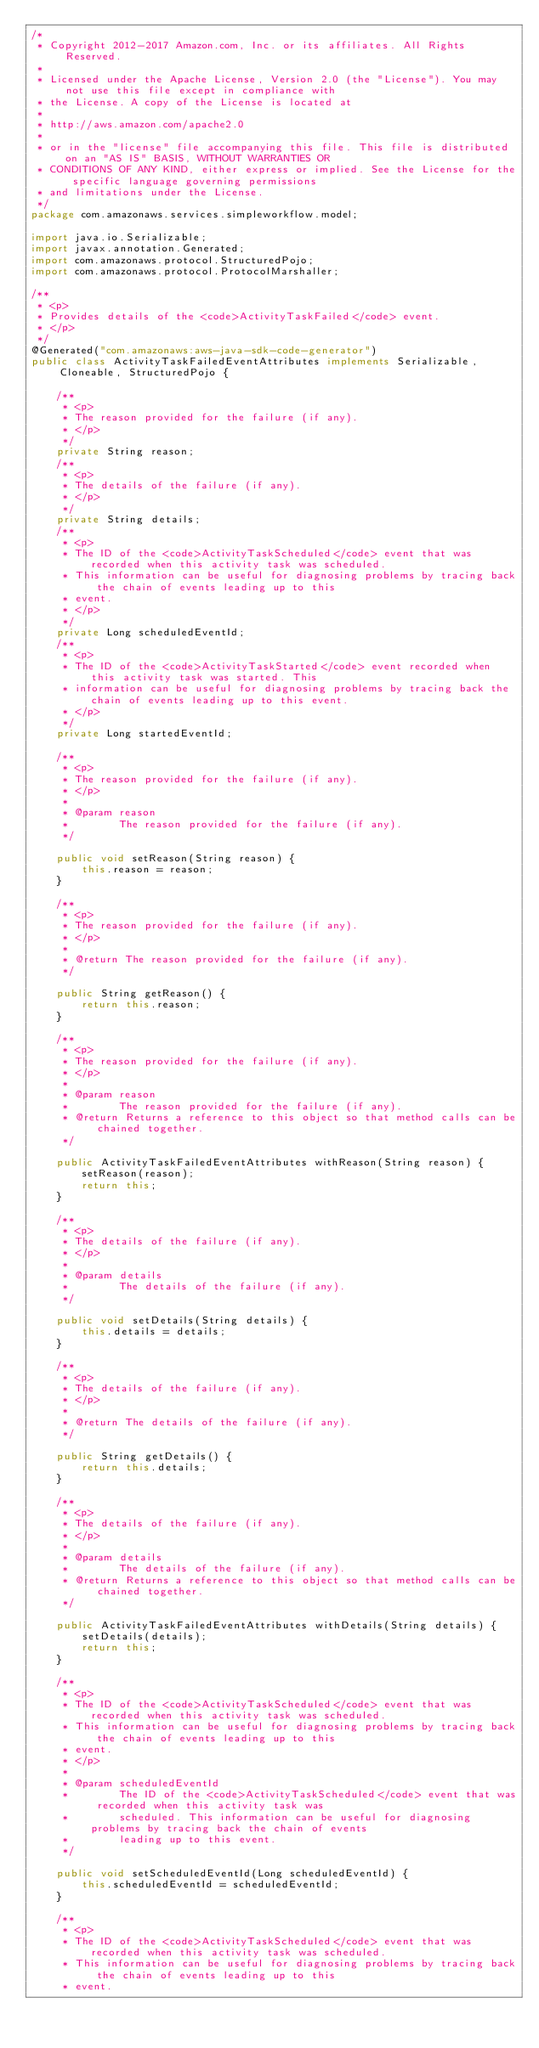Convert code to text. <code><loc_0><loc_0><loc_500><loc_500><_Java_>/*
 * Copyright 2012-2017 Amazon.com, Inc. or its affiliates. All Rights Reserved.
 * 
 * Licensed under the Apache License, Version 2.0 (the "License"). You may not use this file except in compliance with
 * the License. A copy of the License is located at
 * 
 * http://aws.amazon.com/apache2.0
 * 
 * or in the "license" file accompanying this file. This file is distributed on an "AS IS" BASIS, WITHOUT WARRANTIES OR
 * CONDITIONS OF ANY KIND, either express or implied. See the License for the specific language governing permissions
 * and limitations under the License.
 */
package com.amazonaws.services.simpleworkflow.model;

import java.io.Serializable;
import javax.annotation.Generated;
import com.amazonaws.protocol.StructuredPojo;
import com.amazonaws.protocol.ProtocolMarshaller;

/**
 * <p>
 * Provides details of the <code>ActivityTaskFailed</code> event.
 * </p>
 */
@Generated("com.amazonaws:aws-java-sdk-code-generator")
public class ActivityTaskFailedEventAttributes implements Serializable, Cloneable, StructuredPojo {

    /**
     * <p>
     * The reason provided for the failure (if any).
     * </p>
     */
    private String reason;
    /**
     * <p>
     * The details of the failure (if any).
     * </p>
     */
    private String details;
    /**
     * <p>
     * The ID of the <code>ActivityTaskScheduled</code> event that was recorded when this activity task was scheduled.
     * This information can be useful for diagnosing problems by tracing back the chain of events leading up to this
     * event.
     * </p>
     */
    private Long scheduledEventId;
    /**
     * <p>
     * The ID of the <code>ActivityTaskStarted</code> event recorded when this activity task was started. This
     * information can be useful for diagnosing problems by tracing back the chain of events leading up to this event.
     * </p>
     */
    private Long startedEventId;

    /**
     * <p>
     * The reason provided for the failure (if any).
     * </p>
     * 
     * @param reason
     *        The reason provided for the failure (if any).
     */

    public void setReason(String reason) {
        this.reason = reason;
    }

    /**
     * <p>
     * The reason provided for the failure (if any).
     * </p>
     * 
     * @return The reason provided for the failure (if any).
     */

    public String getReason() {
        return this.reason;
    }

    /**
     * <p>
     * The reason provided for the failure (if any).
     * </p>
     * 
     * @param reason
     *        The reason provided for the failure (if any).
     * @return Returns a reference to this object so that method calls can be chained together.
     */

    public ActivityTaskFailedEventAttributes withReason(String reason) {
        setReason(reason);
        return this;
    }

    /**
     * <p>
     * The details of the failure (if any).
     * </p>
     * 
     * @param details
     *        The details of the failure (if any).
     */

    public void setDetails(String details) {
        this.details = details;
    }

    /**
     * <p>
     * The details of the failure (if any).
     * </p>
     * 
     * @return The details of the failure (if any).
     */

    public String getDetails() {
        return this.details;
    }

    /**
     * <p>
     * The details of the failure (if any).
     * </p>
     * 
     * @param details
     *        The details of the failure (if any).
     * @return Returns a reference to this object so that method calls can be chained together.
     */

    public ActivityTaskFailedEventAttributes withDetails(String details) {
        setDetails(details);
        return this;
    }

    /**
     * <p>
     * The ID of the <code>ActivityTaskScheduled</code> event that was recorded when this activity task was scheduled.
     * This information can be useful for diagnosing problems by tracing back the chain of events leading up to this
     * event.
     * </p>
     * 
     * @param scheduledEventId
     *        The ID of the <code>ActivityTaskScheduled</code> event that was recorded when this activity task was
     *        scheduled. This information can be useful for diagnosing problems by tracing back the chain of events
     *        leading up to this event.
     */

    public void setScheduledEventId(Long scheduledEventId) {
        this.scheduledEventId = scheduledEventId;
    }

    /**
     * <p>
     * The ID of the <code>ActivityTaskScheduled</code> event that was recorded when this activity task was scheduled.
     * This information can be useful for diagnosing problems by tracing back the chain of events leading up to this
     * event.</code> 